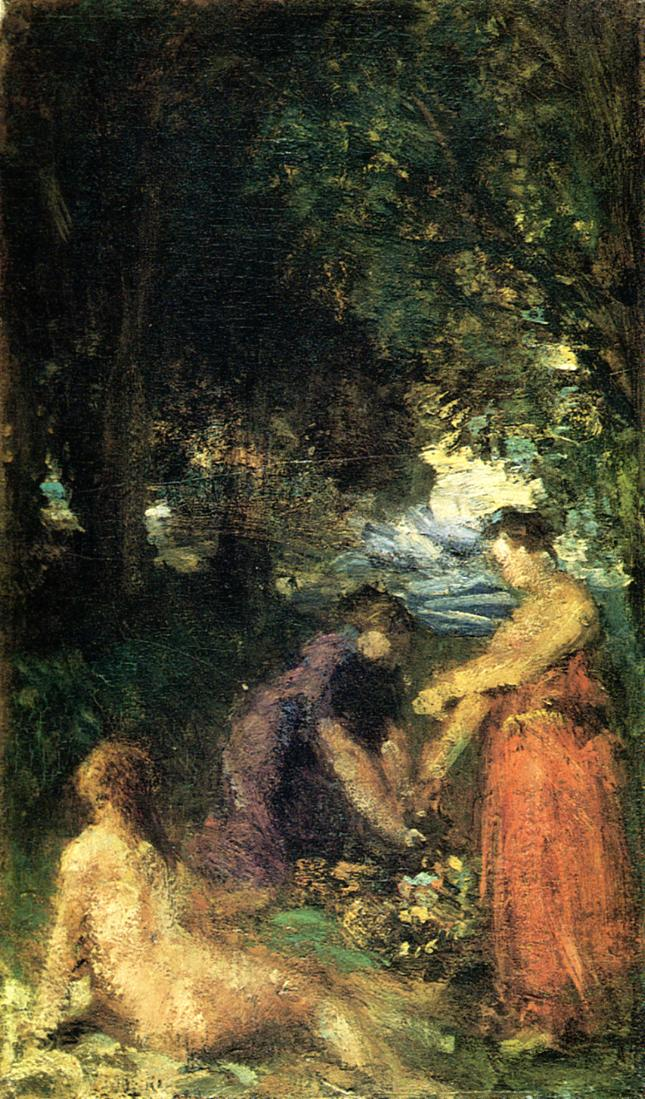This artwork transports me to another world. Can you describe a fantasy setting inspired by this painting? In a mystical forest where the trees whisper secrets of ancient times, a group of forest dwellers bask in the ethereal glow of shimmering lights that dance through the canopy. Among them, nymphs weave garlands of enchanted flowers while faeries flit about, their wings glistening like dew-kissed petals. The air is alive with the symphony of nature - the soft murmur of a nearby brook, the rustle of leaves as woodland creatures play hide and seek, and the distant chime of bells carried by the wind from an unseen faerie festival. This painting is a window to a realm where time stands still, and every brushstroke unveils the hidden magic of a world untouched by the mundane. 